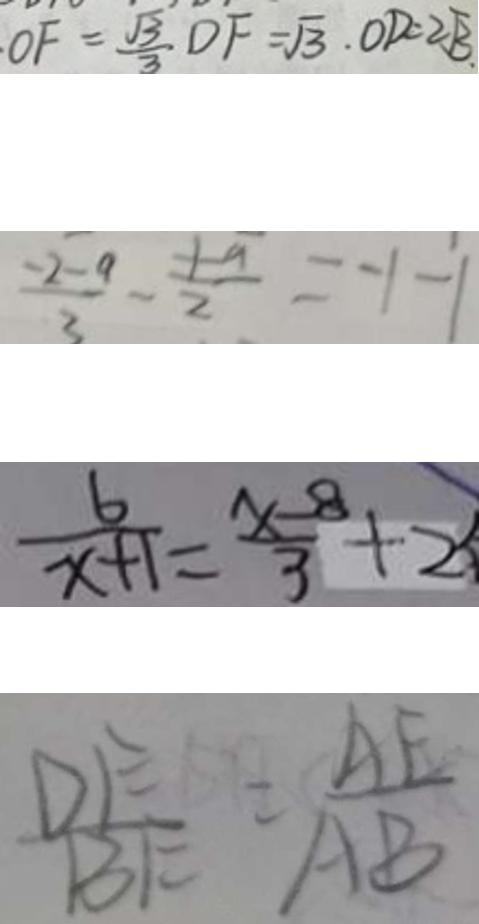<formula> <loc_0><loc_0><loc_500><loc_500>O F = \frac { \sqrt { 3 } } { 3 } D F = \sqrt { 3 } . O D = 2 \sqrt { 3 } 、 
 \frac { - 2 - a } { 3 } - \frac { - 1 - a } { 2 } = - 1 - 1 
 \frac { 6 } { x + 1 } = \frac { x - 8 } { 3 } + 2 
 \frac { D E } { B E } = \frac { A E } { A B }</formula> 